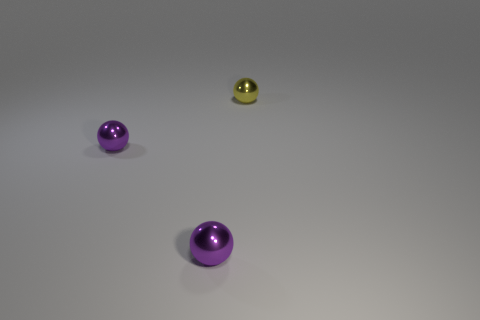Add 1 large green metal blocks. How many objects exist? 4 Add 1 yellow metallic spheres. How many yellow metallic spheres are left? 2 Add 1 small shiny balls. How many small shiny balls exist? 4 Subtract 0 red balls. How many objects are left? 3 Subtract all yellow cubes. Subtract all small yellow things. How many objects are left? 2 